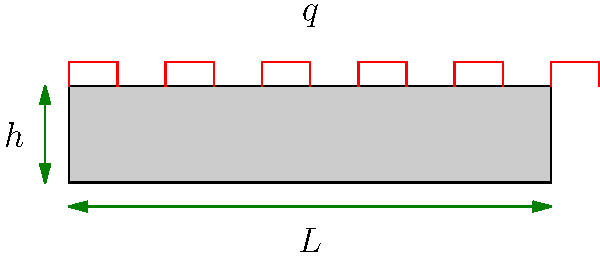As a parent who meticulously plans meals, you understand the importance of precise measurements. Similarly, in civil engineering, accurate calculations are crucial. Consider a concrete slab with length $L = 5$ m that needs to support a uniformly distributed load of $q = 15$ kN/m². If the concrete's allowable bending stress is $\sigma_{allow} = 5$ MPa, estimate the required thickness $h$ of the slab to the nearest centimeter. Let's approach this step-by-step, similar to how you might plan a balanced meal:

1) For a simply supported slab, the maximum bending moment occurs at the center and is given by:

   $$M_{max} = \frac{qL^2}{8}$$

2) Substituting the given values:

   $$M_{max} = \frac{15 \text{ kN/m²} \times (5 \text{ m})^2}{8} = 46.875 \text{ kN⋅m}$$

3) The section modulus (S) for a rectangular section is:

   $$S = \frac{bh^2}{6}$$

   where $b$ is the width (consider 1 m strip) and $h$ is the thickness.

4) The bending stress formula is:

   $$\sigma = \frac{M}{S} \leq \sigma_{allow}$$

5) Substituting and rearranging:

   $$\frac{M_{max}}{\frac{bh^2}{6}} = \sigma_{allow}$$

   $$\frac{46.875 \times 10^6 \text{ N⋅mm}}{1000 \text{ mm} \times h^2} \times 6 = 5 \text{ MPa}$$

6) Solving for $h$:

   $$h^2 = \frac{46.875 \times 10^6 \times 6}{5 \times 1000} = 56250 \text{ mm}^2$$

   $$h = \sqrt{56250} \approx 237 \text{ mm}$$

7) Rounding to the nearest centimeter:

   $$h \approx 24 \text{ cm}$$
Answer: 24 cm 